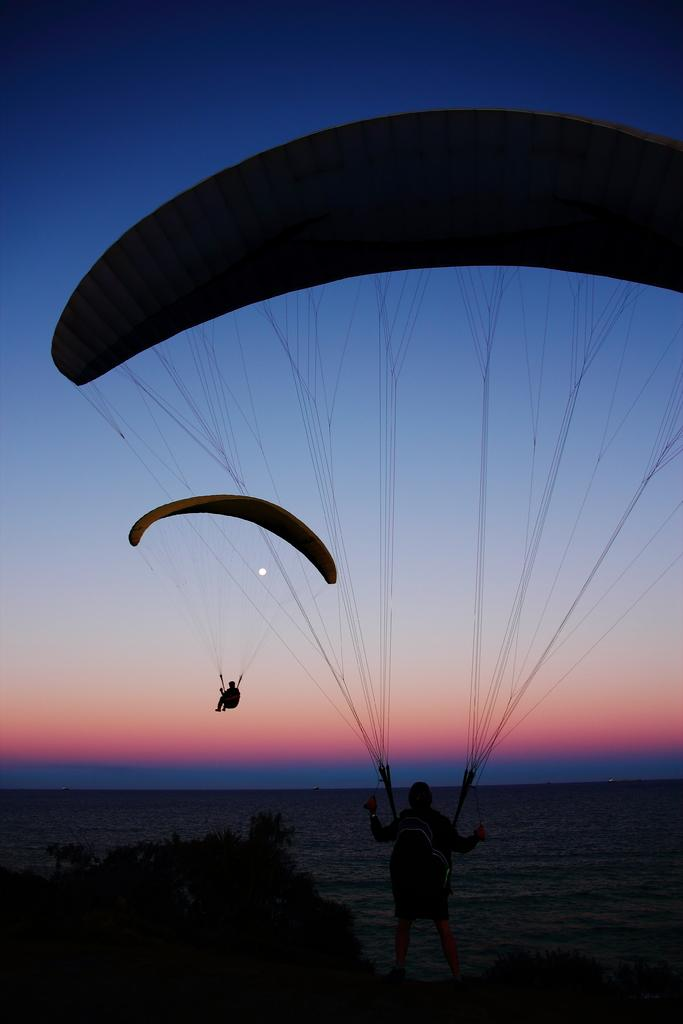What activity are the two people in the image engaged in? The two people in the image are paragliding. What type of landscape can be seen in the image? There are trees and water visible in the image, suggesting a natural landscape. What is visible in the background of the image? The sky and the moon are visible in the background of the image. What type of alley can be seen in the image? There is no alley present in the image; it features two people paragliding in a natural landscape. How many hands are visible in the image? The number of hands visible in the image cannot be determined from the provided facts, as the focus is on the paragliding activity and the landscape. 